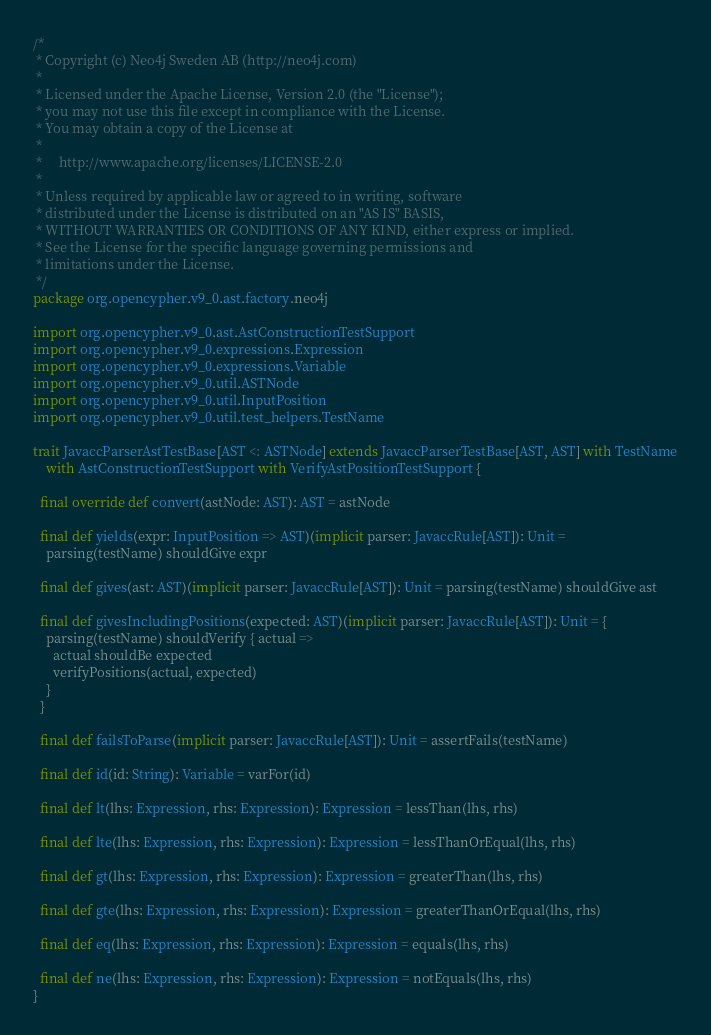Convert code to text. <code><loc_0><loc_0><loc_500><loc_500><_Scala_>/*
 * Copyright (c) Neo4j Sweden AB (http://neo4j.com)
 *
 * Licensed under the Apache License, Version 2.0 (the "License");
 * you may not use this file except in compliance with the License.
 * You may obtain a copy of the License at
 *
 *     http://www.apache.org/licenses/LICENSE-2.0
 *
 * Unless required by applicable law or agreed to in writing, software
 * distributed under the License is distributed on an "AS IS" BASIS,
 * WITHOUT WARRANTIES OR CONDITIONS OF ANY KIND, either express or implied.
 * See the License for the specific language governing permissions and
 * limitations under the License.
 */
package org.opencypher.v9_0.ast.factory.neo4j

import org.opencypher.v9_0.ast.AstConstructionTestSupport
import org.opencypher.v9_0.expressions.Expression
import org.opencypher.v9_0.expressions.Variable
import org.opencypher.v9_0.util.ASTNode
import org.opencypher.v9_0.util.InputPosition
import org.opencypher.v9_0.util.test_helpers.TestName

trait JavaccParserAstTestBase[AST <: ASTNode] extends JavaccParserTestBase[AST, AST] with TestName
    with AstConstructionTestSupport with VerifyAstPositionTestSupport {

  final override def convert(astNode: AST): AST = astNode

  final def yields(expr: InputPosition => AST)(implicit parser: JavaccRule[AST]): Unit =
    parsing(testName) shouldGive expr

  final def gives(ast: AST)(implicit parser: JavaccRule[AST]): Unit = parsing(testName) shouldGive ast

  final def givesIncludingPositions(expected: AST)(implicit parser: JavaccRule[AST]): Unit = {
    parsing(testName) shouldVerify { actual =>
      actual shouldBe expected
      verifyPositions(actual, expected)
    }
  }

  final def failsToParse(implicit parser: JavaccRule[AST]): Unit = assertFails(testName)

  final def id(id: String): Variable = varFor(id)

  final def lt(lhs: Expression, rhs: Expression): Expression = lessThan(lhs, rhs)

  final def lte(lhs: Expression, rhs: Expression): Expression = lessThanOrEqual(lhs, rhs)

  final def gt(lhs: Expression, rhs: Expression): Expression = greaterThan(lhs, rhs)

  final def gte(lhs: Expression, rhs: Expression): Expression = greaterThanOrEqual(lhs, rhs)

  final def eq(lhs: Expression, rhs: Expression): Expression = equals(lhs, rhs)

  final def ne(lhs: Expression, rhs: Expression): Expression = notEquals(lhs, rhs)
}
</code> 